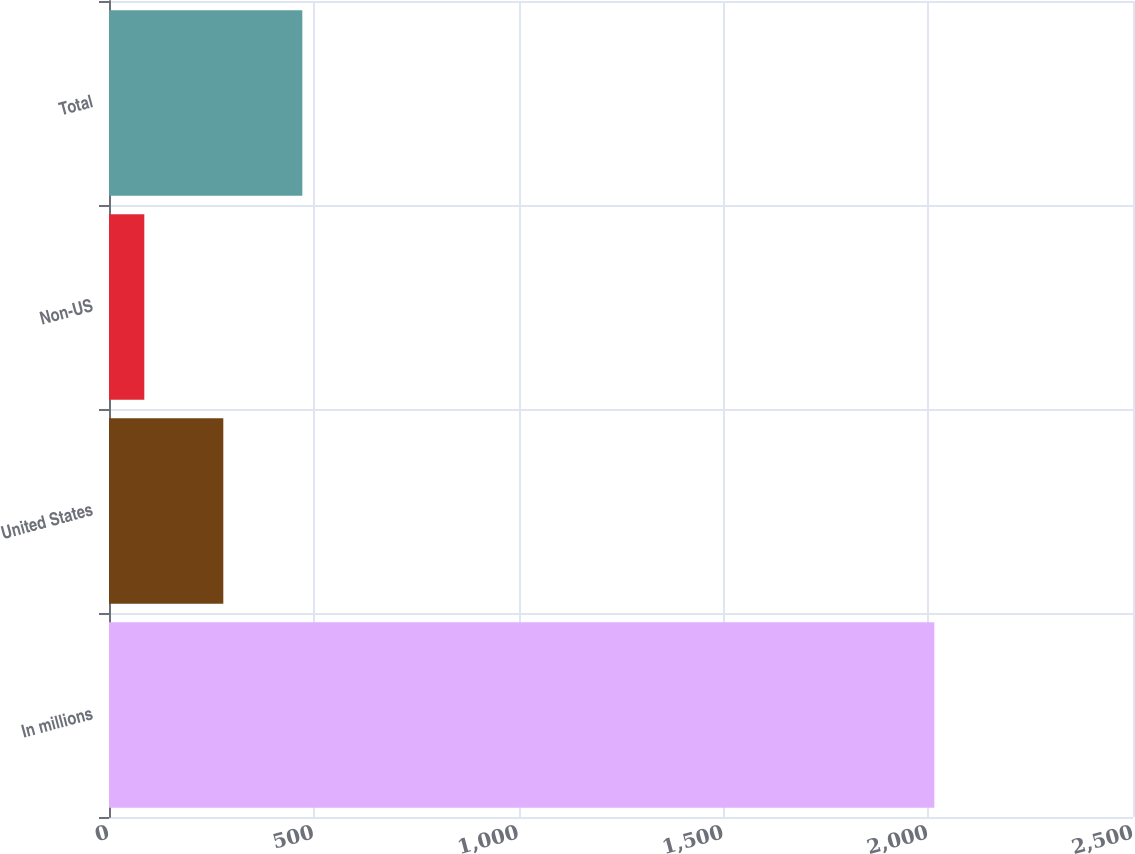Convert chart to OTSL. <chart><loc_0><loc_0><loc_500><loc_500><bar_chart><fcel>In millions<fcel>United States<fcel>Non-US<fcel>Total<nl><fcel>2015<fcel>279.08<fcel>86.2<fcel>471.96<nl></chart> 